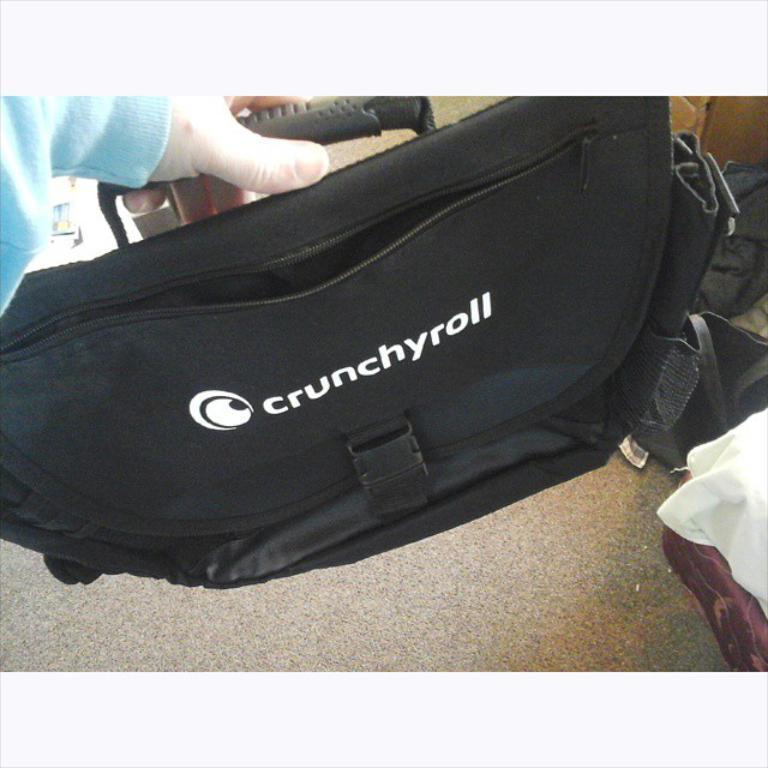Please provide a concise description of this image. In this picture we can see a person's hand who is wearing blue shirt. He is holding a black color bag. On the bottom right corner there is a bed. Near to the bed we can see bags and cloth. 